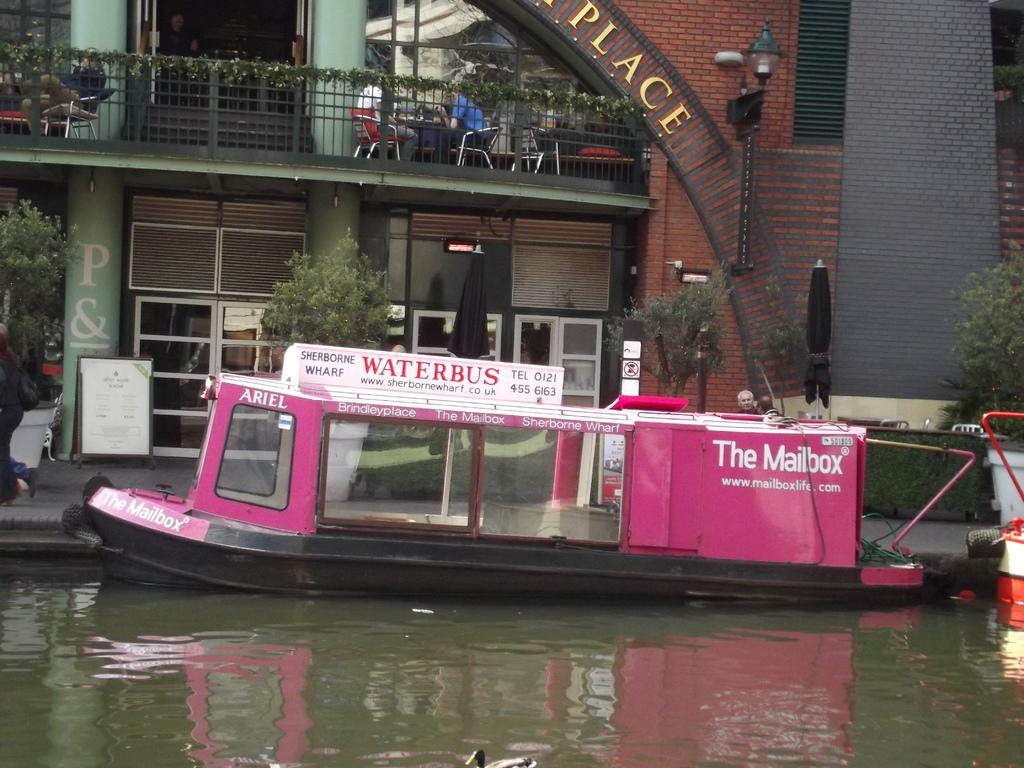Describe this image in one or two sentences. In this image we can see boats and bird on the water, there is a building with some text, light and fence, there are few people sitting on the chairs and there are few trees, umbrellas, a board in front of the building. 